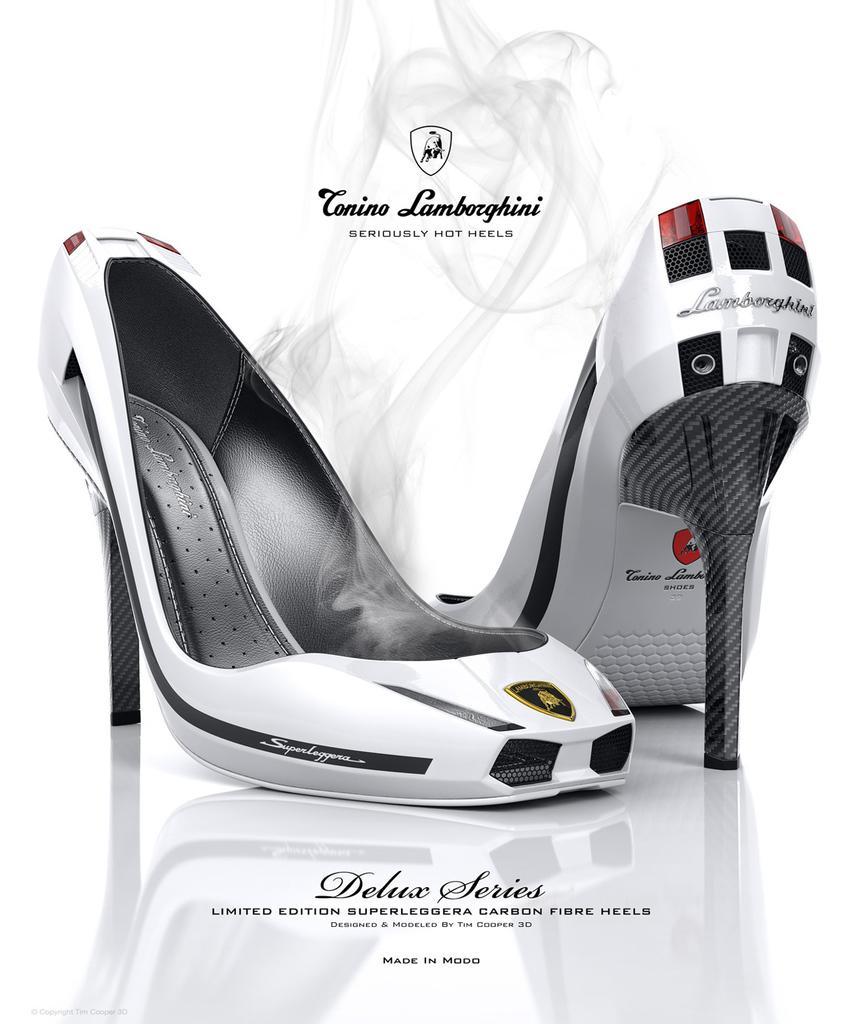Can you describe this image briefly? In this picture I can observe footwear which are in white and black color. I can observe some text on the bottom of the picture. The background is in white color. 